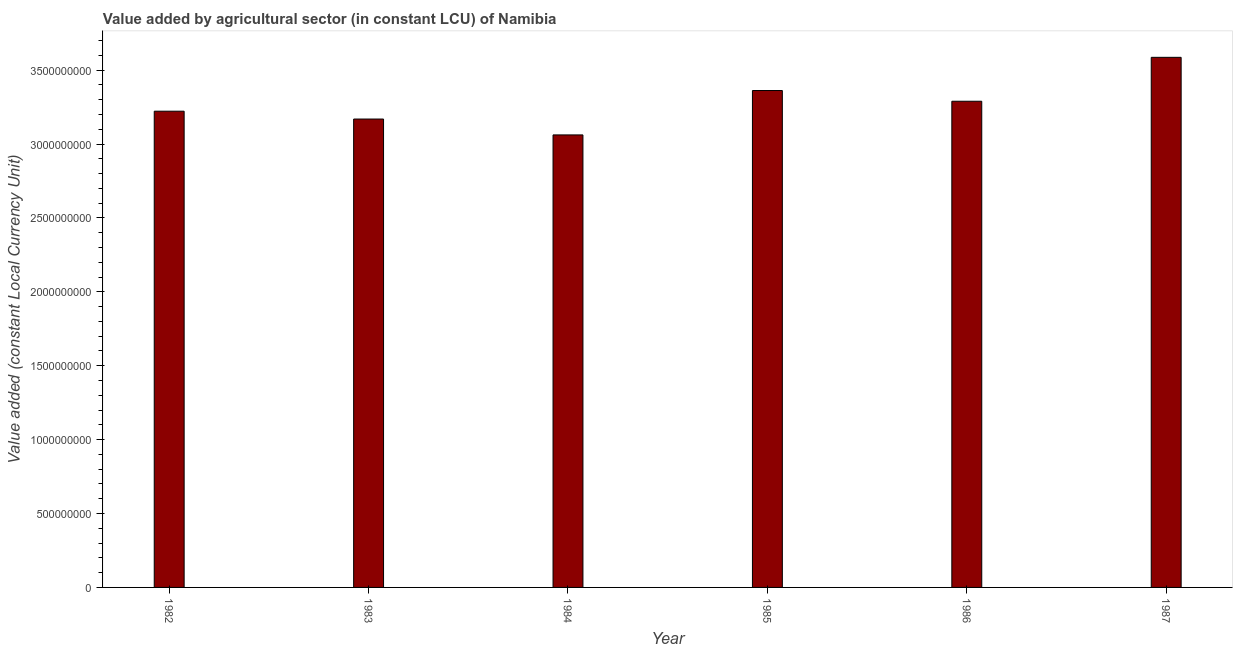Does the graph contain grids?
Provide a succinct answer. No. What is the title of the graph?
Offer a very short reply. Value added by agricultural sector (in constant LCU) of Namibia. What is the label or title of the Y-axis?
Provide a succinct answer. Value added (constant Local Currency Unit). What is the value added by agriculture sector in 1983?
Your answer should be very brief. 3.17e+09. Across all years, what is the maximum value added by agriculture sector?
Offer a terse response. 3.59e+09. Across all years, what is the minimum value added by agriculture sector?
Your answer should be very brief. 3.06e+09. In which year was the value added by agriculture sector maximum?
Your answer should be compact. 1987. What is the sum of the value added by agriculture sector?
Provide a short and direct response. 1.97e+1. What is the difference between the value added by agriculture sector in 1983 and 1986?
Offer a very short reply. -1.20e+08. What is the average value added by agriculture sector per year?
Your answer should be compact. 3.28e+09. What is the median value added by agriculture sector?
Your answer should be compact. 3.26e+09. In how many years, is the value added by agriculture sector greater than 3100000000 LCU?
Offer a terse response. 5. What is the ratio of the value added by agriculture sector in 1986 to that in 1987?
Ensure brevity in your answer.  0.92. Is the value added by agriculture sector in 1983 less than that in 1985?
Keep it short and to the point. Yes. What is the difference between the highest and the second highest value added by agriculture sector?
Ensure brevity in your answer.  2.25e+08. Is the sum of the value added by agriculture sector in 1982 and 1985 greater than the maximum value added by agriculture sector across all years?
Make the answer very short. Yes. What is the difference between the highest and the lowest value added by agriculture sector?
Provide a short and direct response. 5.25e+08. How many bars are there?
Offer a very short reply. 6. What is the difference between two consecutive major ticks on the Y-axis?
Offer a very short reply. 5.00e+08. Are the values on the major ticks of Y-axis written in scientific E-notation?
Keep it short and to the point. No. What is the Value added (constant Local Currency Unit) in 1982?
Offer a terse response. 3.22e+09. What is the Value added (constant Local Currency Unit) of 1983?
Make the answer very short. 3.17e+09. What is the Value added (constant Local Currency Unit) of 1984?
Your answer should be compact. 3.06e+09. What is the Value added (constant Local Currency Unit) of 1985?
Make the answer very short. 3.36e+09. What is the Value added (constant Local Currency Unit) of 1986?
Ensure brevity in your answer.  3.29e+09. What is the Value added (constant Local Currency Unit) of 1987?
Provide a succinct answer. 3.59e+09. What is the difference between the Value added (constant Local Currency Unit) in 1982 and 1983?
Your answer should be very brief. 5.30e+07. What is the difference between the Value added (constant Local Currency Unit) in 1982 and 1984?
Ensure brevity in your answer.  1.60e+08. What is the difference between the Value added (constant Local Currency Unit) in 1982 and 1985?
Make the answer very short. -1.40e+08. What is the difference between the Value added (constant Local Currency Unit) in 1982 and 1986?
Ensure brevity in your answer.  -6.74e+07. What is the difference between the Value added (constant Local Currency Unit) in 1982 and 1987?
Offer a very short reply. -3.64e+08. What is the difference between the Value added (constant Local Currency Unit) in 1983 and 1984?
Your answer should be very brief. 1.07e+08. What is the difference between the Value added (constant Local Currency Unit) in 1983 and 1985?
Give a very brief answer. -1.93e+08. What is the difference between the Value added (constant Local Currency Unit) in 1983 and 1986?
Your answer should be compact. -1.20e+08. What is the difference between the Value added (constant Local Currency Unit) in 1983 and 1987?
Your answer should be compact. -4.17e+08. What is the difference between the Value added (constant Local Currency Unit) in 1984 and 1985?
Your answer should be very brief. -3.00e+08. What is the difference between the Value added (constant Local Currency Unit) in 1984 and 1986?
Give a very brief answer. -2.28e+08. What is the difference between the Value added (constant Local Currency Unit) in 1984 and 1987?
Ensure brevity in your answer.  -5.25e+08. What is the difference between the Value added (constant Local Currency Unit) in 1985 and 1986?
Offer a very short reply. 7.24e+07. What is the difference between the Value added (constant Local Currency Unit) in 1985 and 1987?
Make the answer very short. -2.25e+08. What is the difference between the Value added (constant Local Currency Unit) in 1986 and 1987?
Your answer should be compact. -2.97e+08. What is the ratio of the Value added (constant Local Currency Unit) in 1982 to that in 1983?
Your response must be concise. 1.02. What is the ratio of the Value added (constant Local Currency Unit) in 1982 to that in 1984?
Your answer should be very brief. 1.05. What is the ratio of the Value added (constant Local Currency Unit) in 1982 to that in 1985?
Your response must be concise. 0.96. What is the ratio of the Value added (constant Local Currency Unit) in 1982 to that in 1987?
Your answer should be very brief. 0.9. What is the ratio of the Value added (constant Local Currency Unit) in 1983 to that in 1984?
Provide a short and direct response. 1.03. What is the ratio of the Value added (constant Local Currency Unit) in 1983 to that in 1985?
Make the answer very short. 0.94. What is the ratio of the Value added (constant Local Currency Unit) in 1983 to that in 1987?
Provide a short and direct response. 0.88. What is the ratio of the Value added (constant Local Currency Unit) in 1984 to that in 1985?
Offer a terse response. 0.91. What is the ratio of the Value added (constant Local Currency Unit) in 1984 to that in 1986?
Make the answer very short. 0.93. What is the ratio of the Value added (constant Local Currency Unit) in 1984 to that in 1987?
Keep it short and to the point. 0.85. What is the ratio of the Value added (constant Local Currency Unit) in 1985 to that in 1986?
Provide a short and direct response. 1.02. What is the ratio of the Value added (constant Local Currency Unit) in 1985 to that in 1987?
Provide a short and direct response. 0.94. What is the ratio of the Value added (constant Local Currency Unit) in 1986 to that in 1987?
Make the answer very short. 0.92. 